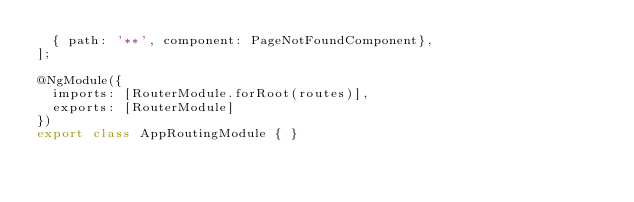<code> <loc_0><loc_0><loc_500><loc_500><_TypeScript_>  { path: '**', component: PageNotFoundComponent},
];

@NgModule({
  imports: [RouterModule.forRoot(routes)],
  exports: [RouterModule]
})
export class AppRoutingModule { }
</code> 